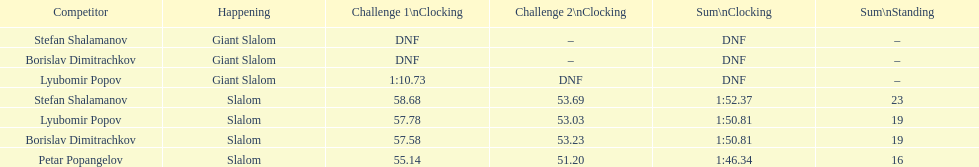Who has the highest rank? Petar Popangelov. 